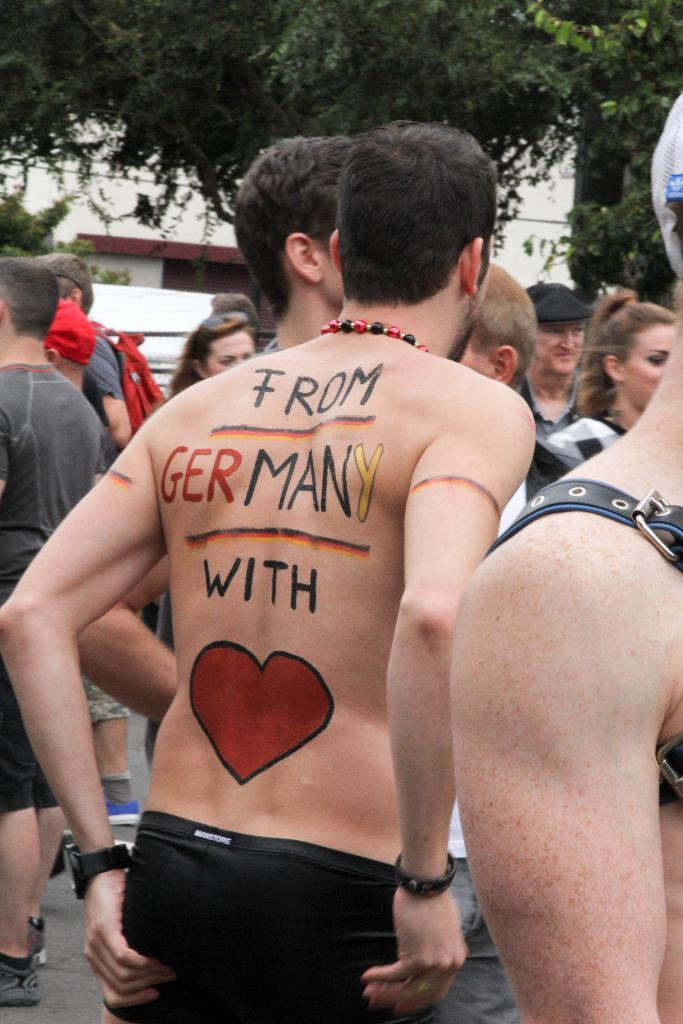What is happening with the group of people in the image? The group of people is on the ground in the image. Can you describe any specific details about one of the people? One person has text on them. What can be seen in the background of the image? There is a building and trees in the background of the image. What type of key is the woman holding in the image? There is no woman or key present in the image. How many arrows are in the quiver that the person is carrying in the image? There is no quiver or arrows present in the image. 